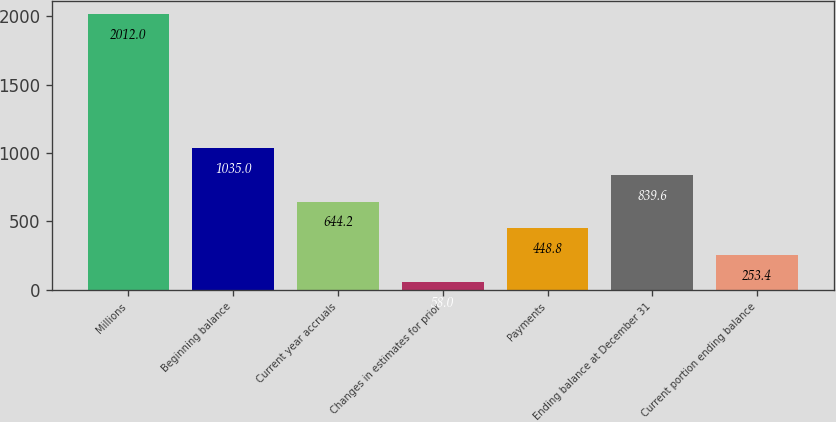Convert chart to OTSL. <chart><loc_0><loc_0><loc_500><loc_500><bar_chart><fcel>Millions<fcel>Beginning balance<fcel>Current year accruals<fcel>Changes in estimates for prior<fcel>Payments<fcel>Ending balance at December 31<fcel>Current portion ending balance<nl><fcel>2012<fcel>1035<fcel>644.2<fcel>58<fcel>448.8<fcel>839.6<fcel>253.4<nl></chart> 